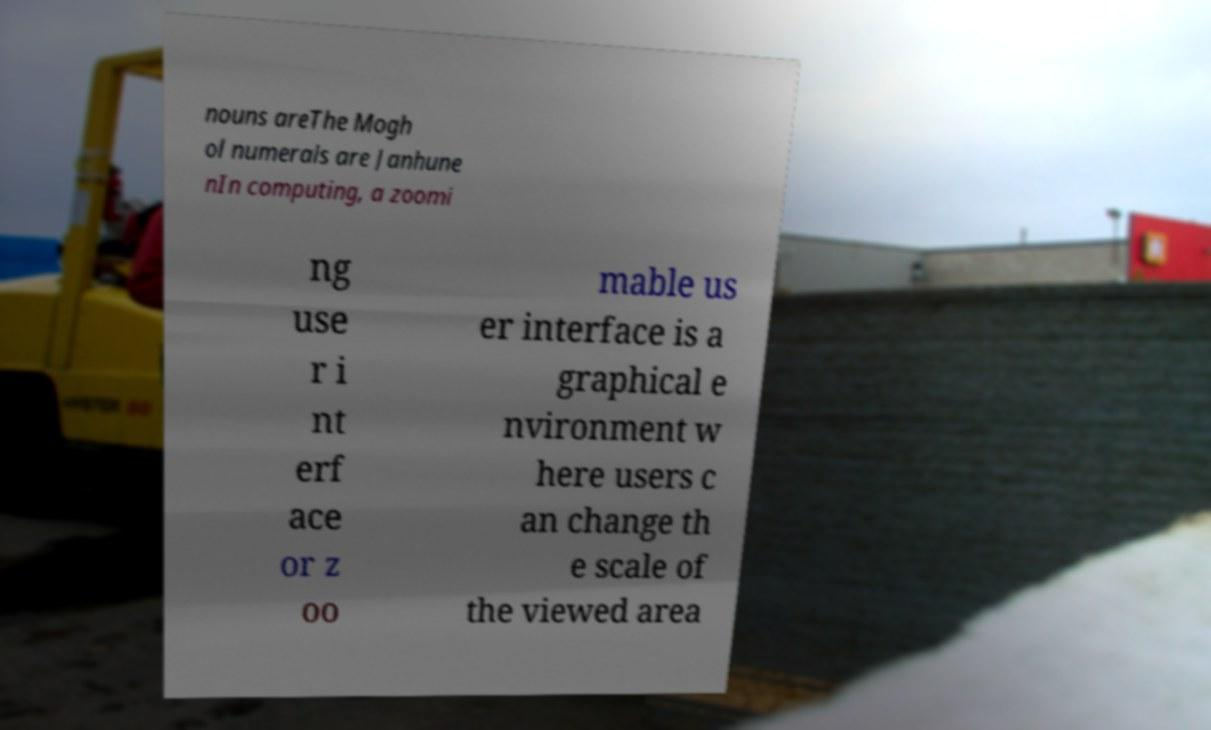Can you read and provide the text displayed in the image?This photo seems to have some interesting text. Can you extract and type it out for me? nouns areThe Mogh ol numerals are Janhune nIn computing, a zoomi ng use r i nt erf ace or z oo mable us er interface is a graphical e nvironment w here users c an change th e scale of the viewed area 